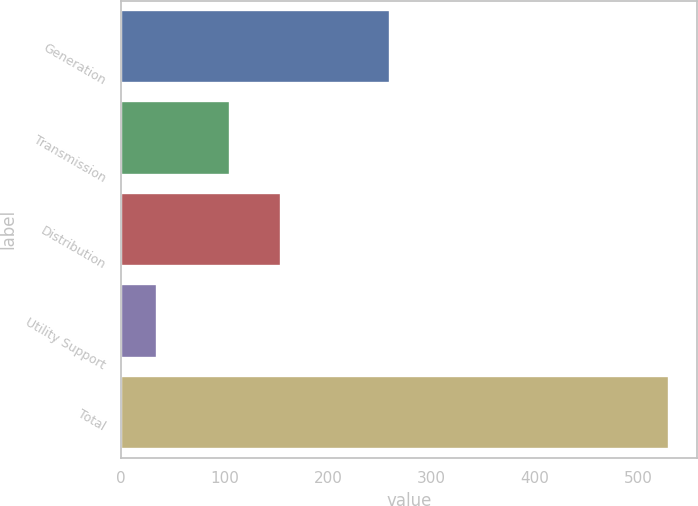Convert chart. <chart><loc_0><loc_0><loc_500><loc_500><bar_chart><fcel>Generation<fcel>Transmission<fcel>Distribution<fcel>Utility Support<fcel>Total<nl><fcel>260<fcel>105<fcel>154.5<fcel>35<fcel>530<nl></chart> 